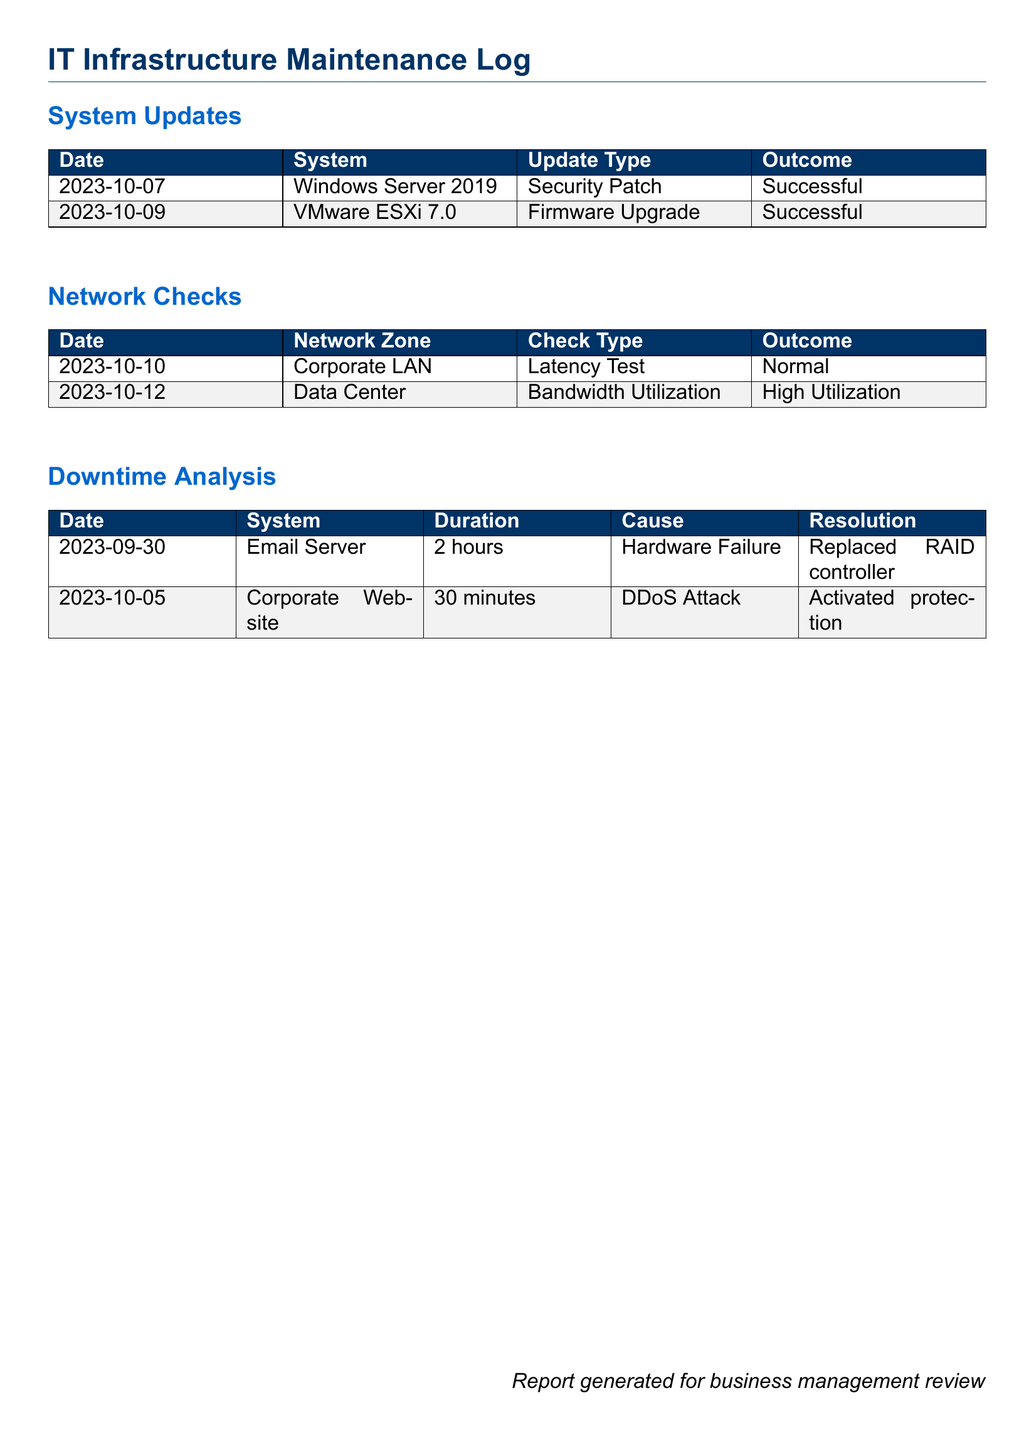What is the date of the last system update? The last system update in the document occurred on 2023-10-09.
Answer: 2023-10-09 What type of update was performed on Windows Server 2019? The type of update performed on Windows Server 2019 was a Security Patch.
Answer: Security Patch What network zone had high bandwidth utilization? The network zone that had high bandwidth utilization is the Data Center.
Answer: Data Center How long was the downtime for the Email Server? The downtime for the Email Server lasted for 2 hours as noted in the downtime analysis.
Answer: 2 hours What was the resolution for the DDoS attack on the corporate website? The resolution for the DDoS attack was to activate protection.
Answer: Activated protection Which system underwent a firmware upgrade? The system that underwent a firmware upgrade was VMware ESXi 7.0.
Answer: VMware ESXi 7.0 What was the cause of the downtime for the Email Server? The cause of the downtime for the Email Server was a Hardware Failure.
Answer: Hardware Failure What was the outcome of the latency test conducted on the Corporate LAN? The outcome of the latency test was Normal.
Answer: Normal How many system updates are listed in the log? There are two system updates listed in the log.
Answer: Two 